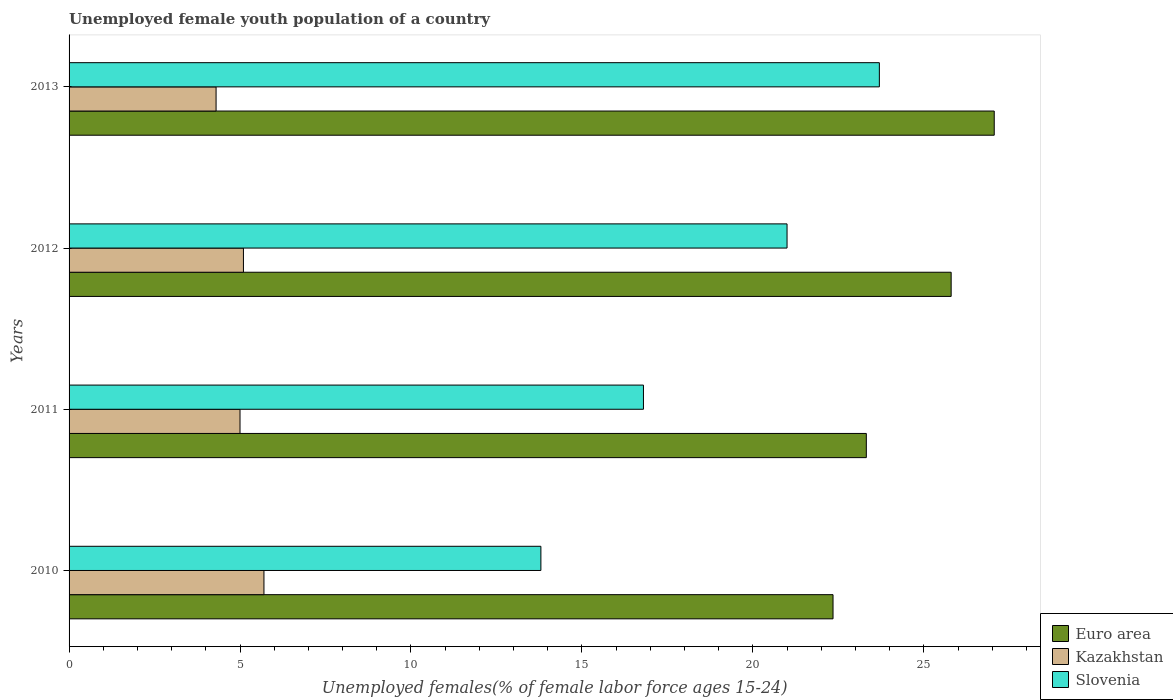How many groups of bars are there?
Ensure brevity in your answer.  4. Are the number of bars on each tick of the Y-axis equal?
Provide a short and direct response. Yes. How many bars are there on the 3rd tick from the bottom?
Offer a terse response. 3. What is the label of the 3rd group of bars from the top?
Make the answer very short. 2011. What is the percentage of unemployed female youth population in Slovenia in 2010?
Provide a succinct answer. 13.8. Across all years, what is the maximum percentage of unemployed female youth population in Euro area?
Provide a succinct answer. 27.06. Across all years, what is the minimum percentage of unemployed female youth population in Euro area?
Keep it short and to the point. 22.34. In which year was the percentage of unemployed female youth population in Kazakhstan maximum?
Keep it short and to the point. 2010. In which year was the percentage of unemployed female youth population in Kazakhstan minimum?
Your answer should be compact. 2013. What is the total percentage of unemployed female youth population in Euro area in the graph?
Your response must be concise. 98.52. What is the difference between the percentage of unemployed female youth population in Euro area in 2010 and that in 2012?
Offer a terse response. -3.46. What is the difference between the percentage of unemployed female youth population in Kazakhstan in 2010 and the percentage of unemployed female youth population in Euro area in 2011?
Provide a succinct answer. -17.62. What is the average percentage of unemployed female youth population in Euro area per year?
Give a very brief answer. 24.63. In the year 2011, what is the difference between the percentage of unemployed female youth population in Euro area and percentage of unemployed female youth population in Kazakhstan?
Keep it short and to the point. 18.32. In how many years, is the percentage of unemployed female youth population in Kazakhstan greater than 10 %?
Keep it short and to the point. 0. What is the ratio of the percentage of unemployed female youth population in Kazakhstan in 2011 to that in 2013?
Offer a terse response. 1.16. Is the difference between the percentage of unemployed female youth population in Euro area in 2010 and 2011 greater than the difference between the percentage of unemployed female youth population in Kazakhstan in 2010 and 2011?
Your response must be concise. No. What is the difference between the highest and the second highest percentage of unemployed female youth population in Slovenia?
Ensure brevity in your answer.  2.7. What is the difference between the highest and the lowest percentage of unemployed female youth population in Slovenia?
Provide a succinct answer. 9.9. What does the 2nd bar from the top in 2011 represents?
Offer a very short reply. Kazakhstan. Are all the bars in the graph horizontal?
Provide a succinct answer. Yes. How many years are there in the graph?
Your answer should be compact. 4. What is the difference between two consecutive major ticks on the X-axis?
Offer a terse response. 5. Are the values on the major ticks of X-axis written in scientific E-notation?
Your answer should be compact. No. Does the graph contain any zero values?
Your answer should be very brief. No. Where does the legend appear in the graph?
Make the answer very short. Bottom right. What is the title of the graph?
Offer a terse response. Unemployed female youth population of a country. Does "United States" appear as one of the legend labels in the graph?
Ensure brevity in your answer.  No. What is the label or title of the X-axis?
Provide a short and direct response. Unemployed females(% of female labor force ages 15-24). What is the Unemployed females(% of female labor force ages 15-24) of Euro area in 2010?
Offer a very short reply. 22.34. What is the Unemployed females(% of female labor force ages 15-24) of Kazakhstan in 2010?
Make the answer very short. 5.7. What is the Unemployed females(% of female labor force ages 15-24) in Slovenia in 2010?
Offer a terse response. 13.8. What is the Unemployed females(% of female labor force ages 15-24) in Euro area in 2011?
Provide a short and direct response. 23.32. What is the Unemployed females(% of female labor force ages 15-24) in Slovenia in 2011?
Make the answer very short. 16.8. What is the Unemployed females(% of female labor force ages 15-24) in Euro area in 2012?
Provide a short and direct response. 25.8. What is the Unemployed females(% of female labor force ages 15-24) of Kazakhstan in 2012?
Your response must be concise. 5.1. What is the Unemployed females(% of female labor force ages 15-24) of Slovenia in 2012?
Your answer should be very brief. 21. What is the Unemployed females(% of female labor force ages 15-24) of Euro area in 2013?
Give a very brief answer. 27.06. What is the Unemployed females(% of female labor force ages 15-24) of Kazakhstan in 2013?
Give a very brief answer. 4.3. What is the Unemployed females(% of female labor force ages 15-24) in Slovenia in 2013?
Provide a short and direct response. 23.7. Across all years, what is the maximum Unemployed females(% of female labor force ages 15-24) in Euro area?
Offer a very short reply. 27.06. Across all years, what is the maximum Unemployed females(% of female labor force ages 15-24) of Kazakhstan?
Provide a short and direct response. 5.7. Across all years, what is the maximum Unemployed females(% of female labor force ages 15-24) of Slovenia?
Offer a very short reply. 23.7. Across all years, what is the minimum Unemployed females(% of female labor force ages 15-24) of Euro area?
Your answer should be compact. 22.34. Across all years, what is the minimum Unemployed females(% of female labor force ages 15-24) of Kazakhstan?
Provide a succinct answer. 4.3. Across all years, what is the minimum Unemployed females(% of female labor force ages 15-24) in Slovenia?
Ensure brevity in your answer.  13.8. What is the total Unemployed females(% of female labor force ages 15-24) of Euro area in the graph?
Your response must be concise. 98.52. What is the total Unemployed females(% of female labor force ages 15-24) in Kazakhstan in the graph?
Your response must be concise. 20.1. What is the total Unemployed females(% of female labor force ages 15-24) of Slovenia in the graph?
Your answer should be compact. 75.3. What is the difference between the Unemployed females(% of female labor force ages 15-24) in Euro area in 2010 and that in 2011?
Keep it short and to the point. -0.97. What is the difference between the Unemployed females(% of female labor force ages 15-24) of Slovenia in 2010 and that in 2011?
Ensure brevity in your answer.  -3. What is the difference between the Unemployed females(% of female labor force ages 15-24) in Euro area in 2010 and that in 2012?
Provide a short and direct response. -3.46. What is the difference between the Unemployed females(% of female labor force ages 15-24) of Slovenia in 2010 and that in 2012?
Your answer should be compact. -7.2. What is the difference between the Unemployed females(% of female labor force ages 15-24) of Euro area in 2010 and that in 2013?
Offer a terse response. -4.71. What is the difference between the Unemployed females(% of female labor force ages 15-24) of Kazakhstan in 2010 and that in 2013?
Offer a terse response. 1.4. What is the difference between the Unemployed females(% of female labor force ages 15-24) of Slovenia in 2010 and that in 2013?
Provide a succinct answer. -9.9. What is the difference between the Unemployed females(% of female labor force ages 15-24) in Euro area in 2011 and that in 2012?
Offer a terse response. -2.48. What is the difference between the Unemployed females(% of female labor force ages 15-24) of Kazakhstan in 2011 and that in 2012?
Your answer should be very brief. -0.1. What is the difference between the Unemployed females(% of female labor force ages 15-24) in Euro area in 2011 and that in 2013?
Your answer should be very brief. -3.74. What is the difference between the Unemployed females(% of female labor force ages 15-24) in Kazakhstan in 2011 and that in 2013?
Ensure brevity in your answer.  0.7. What is the difference between the Unemployed females(% of female labor force ages 15-24) of Euro area in 2012 and that in 2013?
Your answer should be very brief. -1.26. What is the difference between the Unemployed females(% of female labor force ages 15-24) of Kazakhstan in 2012 and that in 2013?
Keep it short and to the point. 0.8. What is the difference between the Unemployed females(% of female labor force ages 15-24) in Euro area in 2010 and the Unemployed females(% of female labor force ages 15-24) in Kazakhstan in 2011?
Keep it short and to the point. 17.34. What is the difference between the Unemployed females(% of female labor force ages 15-24) in Euro area in 2010 and the Unemployed females(% of female labor force ages 15-24) in Slovenia in 2011?
Provide a short and direct response. 5.54. What is the difference between the Unemployed females(% of female labor force ages 15-24) of Euro area in 2010 and the Unemployed females(% of female labor force ages 15-24) of Kazakhstan in 2012?
Offer a terse response. 17.24. What is the difference between the Unemployed females(% of female labor force ages 15-24) of Euro area in 2010 and the Unemployed females(% of female labor force ages 15-24) of Slovenia in 2012?
Your response must be concise. 1.34. What is the difference between the Unemployed females(% of female labor force ages 15-24) in Kazakhstan in 2010 and the Unemployed females(% of female labor force ages 15-24) in Slovenia in 2012?
Give a very brief answer. -15.3. What is the difference between the Unemployed females(% of female labor force ages 15-24) of Euro area in 2010 and the Unemployed females(% of female labor force ages 15-24) of Kazakhstan in 2013?
Your response must be concise. 18.04. What is the difference between the Unemployed females(% of female labor force ages 15-24) of Euro area in 2010 and the Unemployed females(% of female labor force ages 15-24) of Slovenia in 2013?
Provide a short and direct response. -1.36. What is the difference between the Unemployed females(% of female labor force ages 15-24) of Kazakhstan in 2010 and the Unemployed females(% of female labor force ages 15-24) of Slovenia in 2013?
Make the answer very short. -18. What is the difference between the Unemployed females(% of female labor force ages 15-24) of Euro area in 2011 and the Unemployed females(% of female labor force ages 15-24) of Kazakhstan in 2012?
Provide a short and direct response. 18.22. What is the difference between the Unemployed females(% of female labor force ages 15-24) in Euro area in 2011 and the Unemployed females(% of female labor force ages 15-24) in Slovenia in 2012?
Keep it short and to the point. 2.32. What is the difference between the Unemployed females(% of female labor force ages 15-24) in Kazakhstan in 2011 and the Unemployed females(% of female labor force ages 15-24) in Slovenia in 2012?
Keep it short and to the point. -16. What is the difference between the Unemployed females(% of female labor force ages 15-24) of Euro area in 2011 and the Unemployed females(% of female labor force ages 15-24) of Kazakhstan in 2013?
Offer a very short reply. 19.02. What is the difference between the Unemployed females(% of female labor force ages 15-24) in Euro area in 2011 and the Unemployed females(% of female labor force ages 15-24) in Slovenia in 2013?
Give a very brief answer. -0.38. What is the difference between the Unemployed females(% of female labor force ages 15-24) of Kazakhstan in 2011 and the Unemployed females(% of female labor force ages 15-24) of Slovenia in 2013?
Provide a short and direct response. -18.7. What is the difference between the Unemployed females(% of female labor force ages 15-24) in Euro area in 2012 and the Unemployed females(% of female labor force ages 15-24) in Kazakhstan in 2013?
Keep it short and to the point. 21.5. What is the difference between the Unemployed females(% of female labor force ages 15-24) in Euro area in 2012 and the Unemployed females(% of female labor force ages 15-24) in Slovenia in 2013?
Your answer should be compact. 2.1. What is the difference between the Unemployed females(% of female labor force ages 15-24) of Kazakhstan in 2012 and the Unemployed females(% of female labor force ages 15-24) of Slovenia in 2013?
Provide a succinct answer. -18.6. What is the average Unemployed females(% of female labor force ages 15-24) of Euro area per year?
Offer a very short reply. 24.63. What is the average Unemployed females(% of female labor force ages 15-24) in Kazakhstan per year?
Your answer should be very brief. 5.03. What is the average Unemployed females(% of female labor force ages 15-24) of Slovenia per year?
Ensure brevity in your answer.  18.82. In the year 2010, what is the difference between the Unemployed females(% of female labor force ages 15-24) of Euro area and Unemployed females(% of female labor force ages 15-24) of Kazakhstan?
Offer a terse response. 16.64. In the year 2010, what is the difference between the Unemployed females(% of female labor force ages 15-24) of Euro area and Unemployed females(% of female labor force ages 15-24) of Slovenia?
Offer a very short reply. 8.54. In the year 2010, what is the difference between the Unemployed females(% of female labor force ages 15-24) of Kazakhstan and Unemployed females(% of female labor force ages 15-24) of Slovenia?
Your answer should be compact. -8.1. In the year 2011, what is the difference between the Unemployed females(% of female labor force ages 15-24) of Euro area and Unemployed females(% of female labor force ages 15-24) of Kazakhstan?
Your response must be concise. 18.32. In the year 2011, what is the difference between the Unemployed females(% of female labor force ages 15-24) in Euro area and Unemployed females(% of female labor force ages 15-24) in Slovenia?
Your answer should be compact. 6.52. In the year 2012, what is the difference between the Unemployed females(% of female labor force ages 15-24) of Euro area and Unemployed females(% of female labor force ages 15-24) of Kazakhstan?
Provide a short and direct response. 20.7. In the year 2012, what is the difference between the Unemployed females(% of female labor force ages 15-24) in Euro area and Unemployed females(% of female labor force ages 15-24) in Slovenia?
Provide a succinct answer. 4.8. In the year 2012, what is the difference between the Unemployed females(% of female labor force ages 15-24) in Kazakhstan and Unemployed females(% of female labor force ages 15-24) in Slovenia?
Your answer should be very brief. -15.9. In the year 2013, what is the difference between the Unemployed females(% of female labor force ages 15-24) in Euro area and Unemployed females(% of female labor force ages 15-24) in Kazakhstan?
Provide a succinct answer. 22.76. In the year 2013, what is the difference between the Unemployed females(% of female labor force ages 15-24) in Euro area and Unemployed females(% of female labor force ages 15-24) in Slovenia?
Provide a succinct answer. 3.36. In the year 2013, what is the difference between the Unemployed females(% of female labor force ages 15-24) in Kazakhstan and Unemployed females(% of female labor force ages 15-24) in Slovenia?
Provide a short and direct response. -19.4. What is the ratio of the Unemployed females(% of female labor force ages 15-24) in Euro area in 2010 to that in 2011?
Give a very brief answer. 0.96. What is the ratio of the Unemployed females(% of female labor force ages 15-24) in Kazakhstan in 2010 to that in 2011?
Provide a succinct answer. 1.14. What is the ratio of the Unemployed females(% of female labor force ages 15-24) in Slovenia in 2010 to that in 2011?
Keep it short and to the point. 0.82. What is the ratio of the Unemployed females(% of female labor force ages 15-24) in Euro area in 2010 to that in 2012?
Keep it short and to the point. 0.87. What is the ratio of the Unemployed females(% of female labor force ages 15-24) of Kazakhstan in 2010 to that in 2012?
Keep it short and to the point. 1.12. What is the ratio of the Unemployed females(% of female labor force ages 15-24) in Slovenia in 2010 to that in 2012?
Keep it short and to the point. 0.66. What is the ratio of the Unemployed females(% of female labor force ages 15-24) of Euro area in 2010 to that in 2013?
Give a very brief answer. 0.83. What is the ratio of the Unemployed females(% of female labor force ages 15-24) in Kazakhstan in 2010 to that in 2013?
Provide a succinct answer. 1.33. What is the ratio of the Unemployed females(% of female labor force ages 15-24) of Slovenia in 2010 to that in 2013?
Keep it short and to the point. 0.58. What is the ratio of the Unemployed females(% of female labor force ages 15-24) of Euro area in 2011 to that in 2012?
Provide a succinct answer. 0.9. What is the ratio of the Unemployed females(% of female labor force ages 15-24) in Kazakhstan in 2011 to that in 2012?
Make the answer very short. 0.98. What is the ratio of the Unemployed females(% of female labor force ages 15-24) in Slovenia in 2011 to that in 2012?
Provide a short and direct response. 0.8. What is the ratio of the Unemployed females(% of female labor force ages 15-24) of Euro area in 2011 to that in 2013?
Ensure brevity in your answer.  0.86. What is the ratio of the Unemployed females(% of female labor force ages 15-24) in Kazakhstan in 2011 to that in 2013?
Make the answer very short. 1.16. What is the ratio of the Unemployed females(% of female labor force ages 15-24) of Slovenia in 2011 to that in 2013?
Give a very brief answer. 0.71. What is the ratio of the Unemployed females(% of female labor force ages 15-24) in Euro area in 2012 to that in 2013?
Your answer should be compact. 0.95. What is the ratio of the Unemployed females(% of female labor force ages 15-24) in Kazakhstan in 2012 to that in 2013?
Provide a short and direct response. 1.19. What is the ratio of the Unemployed females(% of female labor force ages 15-24) in Slovenia in 2012 to that in 2013?
Your answer should be compact. 0.89. What is the difference between the highest and the second highest Unemployed females(% of female labor force ages 15-24) in Euro area?
Make the answer very short. 1.26. What is the difference between the highest and the second highest Unemployed females(% of female labor force ages 15-24) of Kazakhstan?
Ensure brevity in your answer.  0.6. What is the difference between the highest and the second highest Unemployed females(% of female labor force ages 15-24) of Slovenia?
Provide a short and direct response. 2.7. What is the difference between the highest and the lowest Unemployed females(% of female labor force ages 15-24) of Euro area?
Offer a terse response. 4.71. What is the difference between the highest and the lowest Unemployed females(% of female labor force ages 15-24) in Kazakhstan?
Keep it short and to the point. 1.4. What is the difference between the highest and the lowest Unemployed females(% of female labor force ages 15-24) of Slovenia?
Provide a short and direct response. 9.9. 